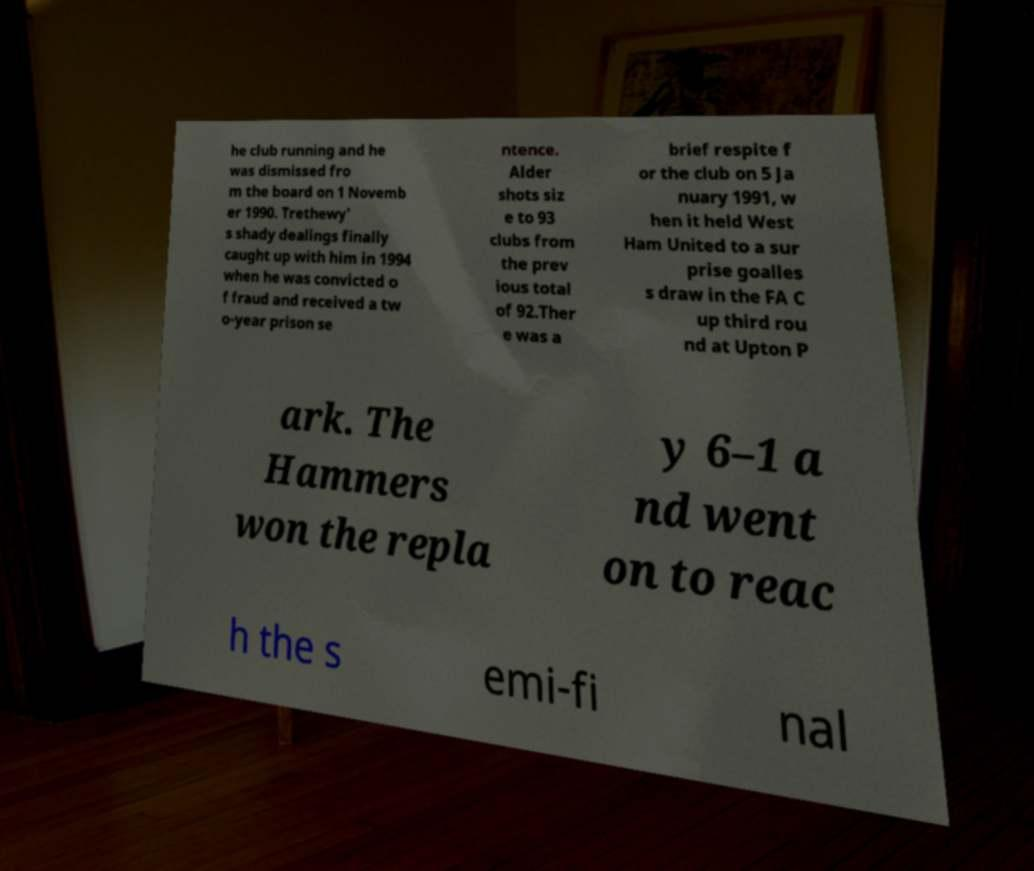Could you assist in decoding the text presented in this image and type it out clearly? he club running and he was dismissed fro m the board on 1 Novemb er 1990. Trethewy' s shady dealings finally caught up with him in 1994 when he was convicted o f fraud and received a tw o-year prison se ntence. Alder shots siz e to 93 clubs from the prev ious total of 92.Ther e was a brief respite f or the club on 5 Ja nuary 1991, w hen it held West Ham United to a sur prise goalles s draw in the FA C up third rou nd at Upton P ark. The Hammers won the repla y 6–1 a nd went on to reac h the s emi-fi nal 